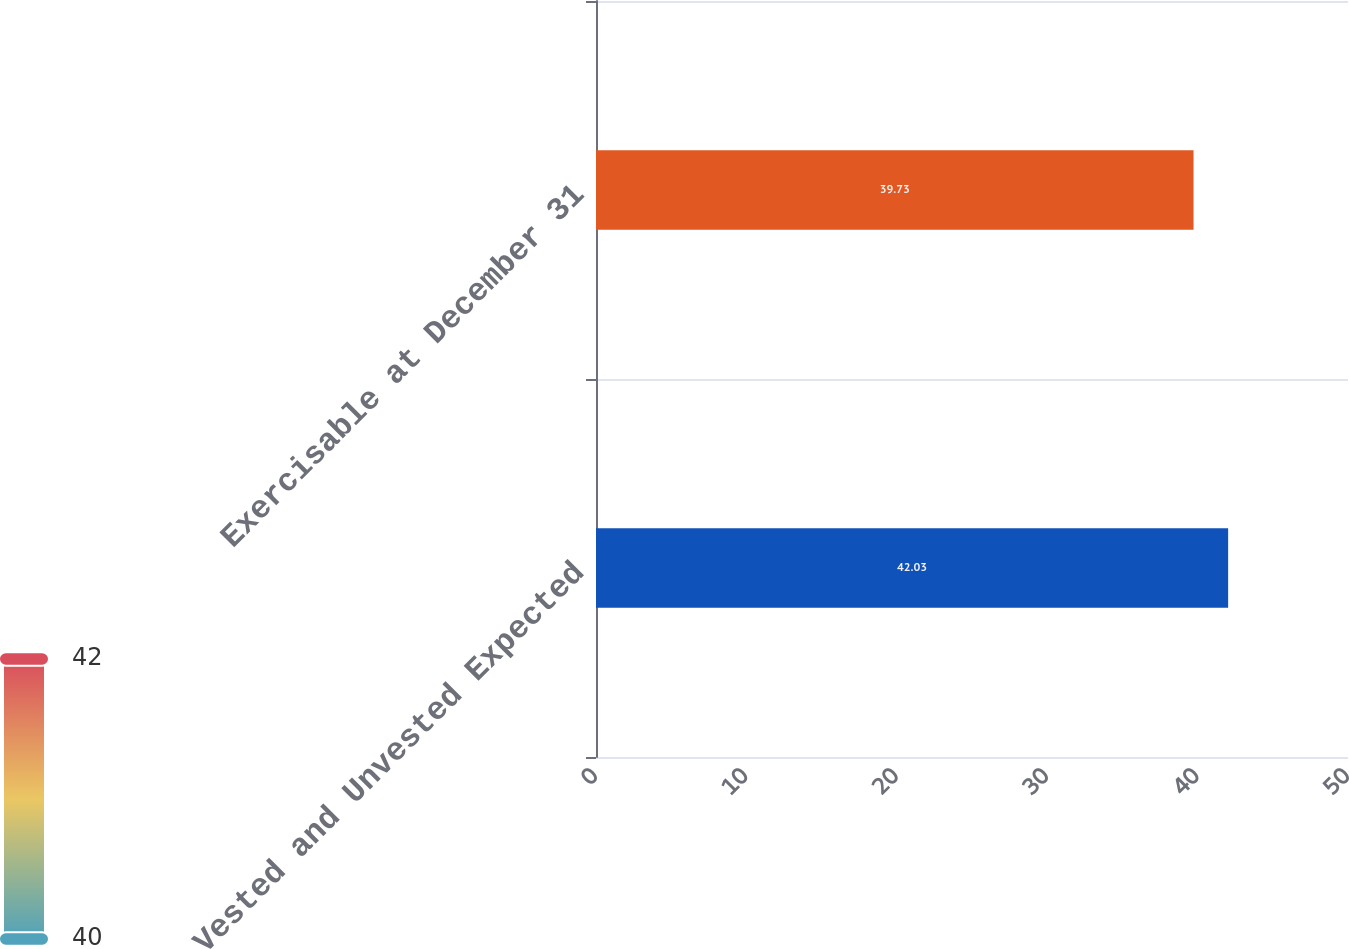Convert chart to OTSL. <chart><loc_0><loc_0><loc_500><loc_500><bar_chart><fcel>Vested and Unvested Expected<fcel>Exercisable at December 31<nl><fcel>42.03<fcel>39.73<nl></chart> 